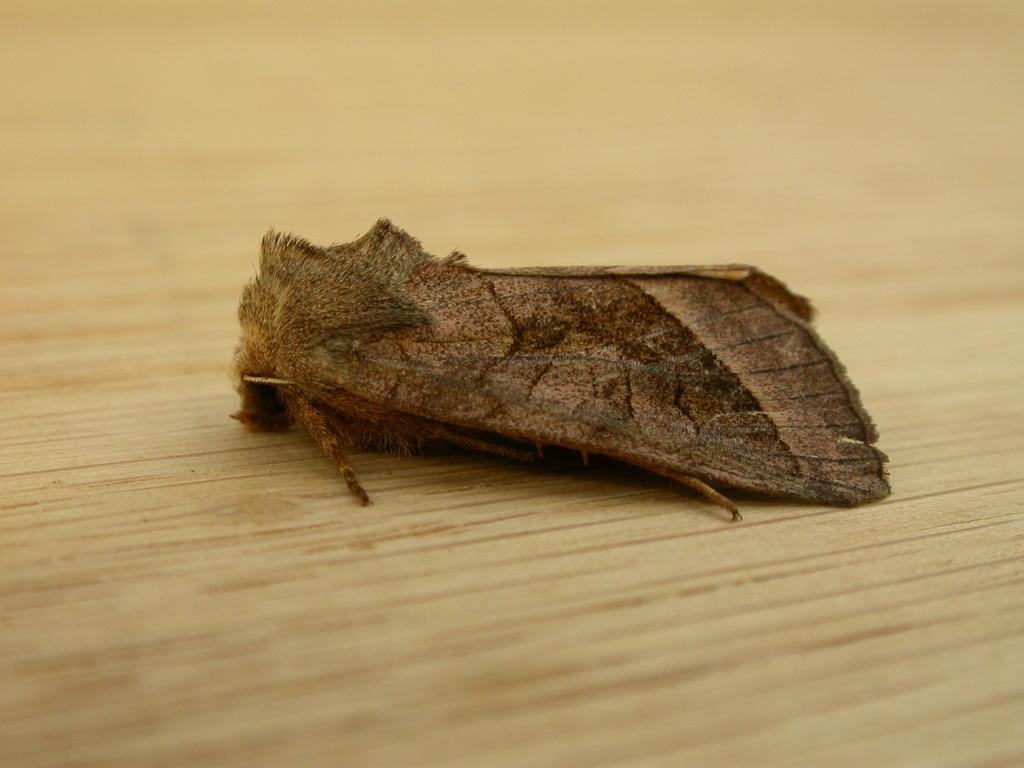What type of creature can be seen in the image? There is an insect in the image. What color is the insect? The insect is brown in color. What type of surface is at the bottom of the image? There is a wooden floor at the bottom of the image. What type of horn is the insect using to communicate in the image? There is no horn present in the image, and insects do not use horns to communicate. 